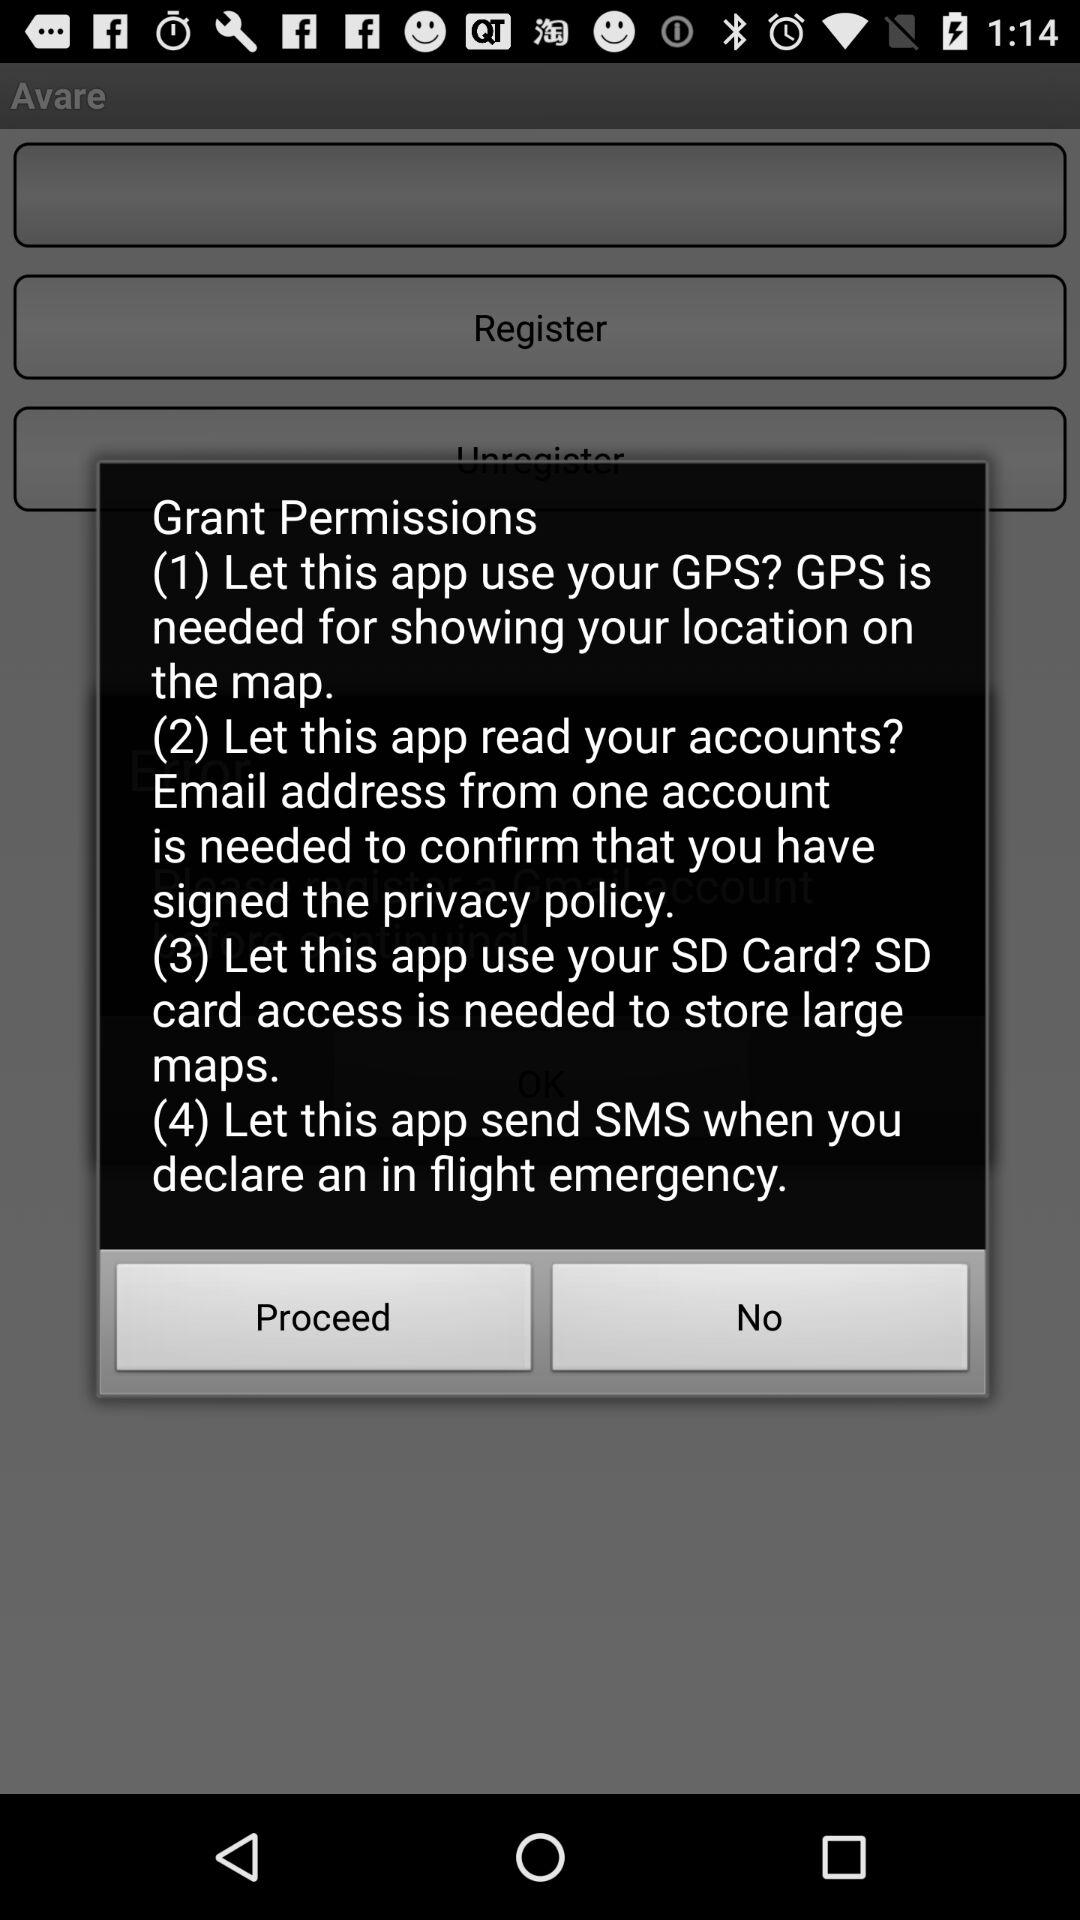How many permissions are requested by this app?
Answer the question using a single word or phrase. 4 